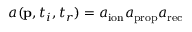<formula> <loc_0><loc_0><loc_500><loc_500>a ( p , t _ { i } , t _ { r } ) = a _ { i o n } a _ { p r o p } a _ { r e c }</formula> 